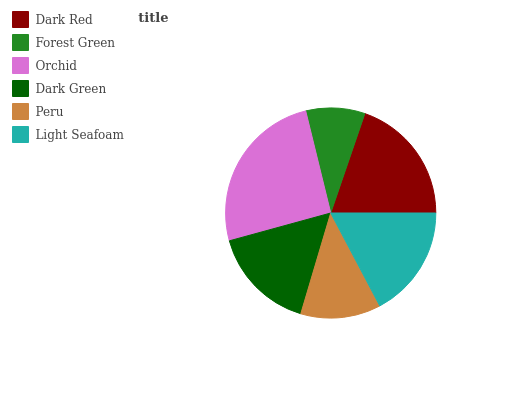Is Forest Green the minimum?
Answer yes or no. Yes. Is Orchid the maximum?
Answer yes or no. Yes. Is Orchid the minimum?
Answer yes or no. No. Is Forest Green the maximum?
Answer yes or no. No. Is Orchid greater than Forest Green?
Answer yes or no. Yes. Is Forest Green less than Orchid?
Answer yes or no. Yes. Is Forest Green greater than Orchid?
Answer yes or no. No. Is Orchid less than Forest Green?
Answer yes or no. No. Is Light Seafoam the high median?
Answer yes or no. Yes. Is Dark Green the low median?
Answer yes or no. Yes. Is Dark Green the high median?
Answer yes or no. No. Is Forest Green the low median?
Answer yes or no. No. 